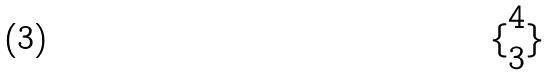Convert formula to latex. <formula><loc_0><loc_0><loc_500><loc_500>\{ \begin{matrix} 4 \\ 3 \end{matrix} \}</formula> 